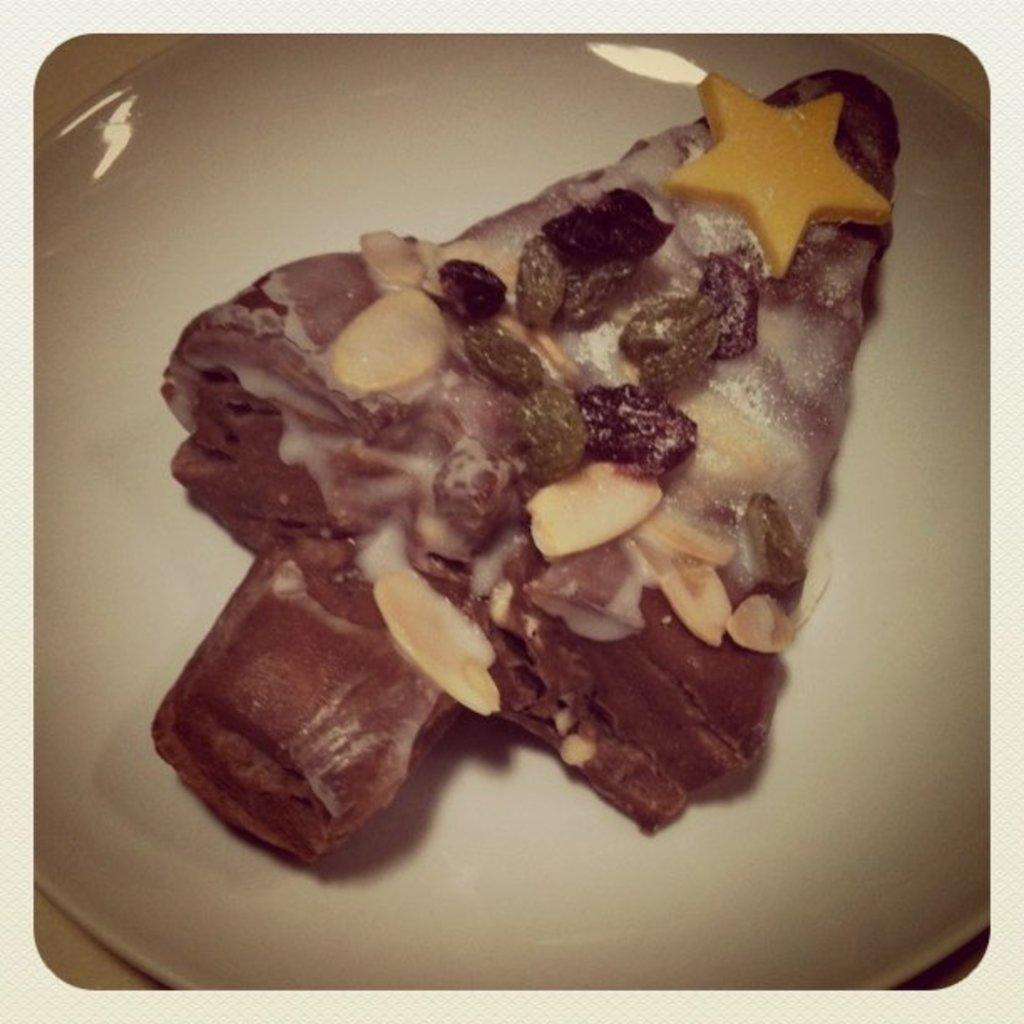What type of plate is visible in the image? There is a cream-colored plate in the image. What is on the plate? There is a food item on the plate. Can you describe the colors of the food item? The food item has brown, cream, red, and yellow colors. Is there a quiver of arrows visible in the image? No, there is no quiver of arrows present in the image. 